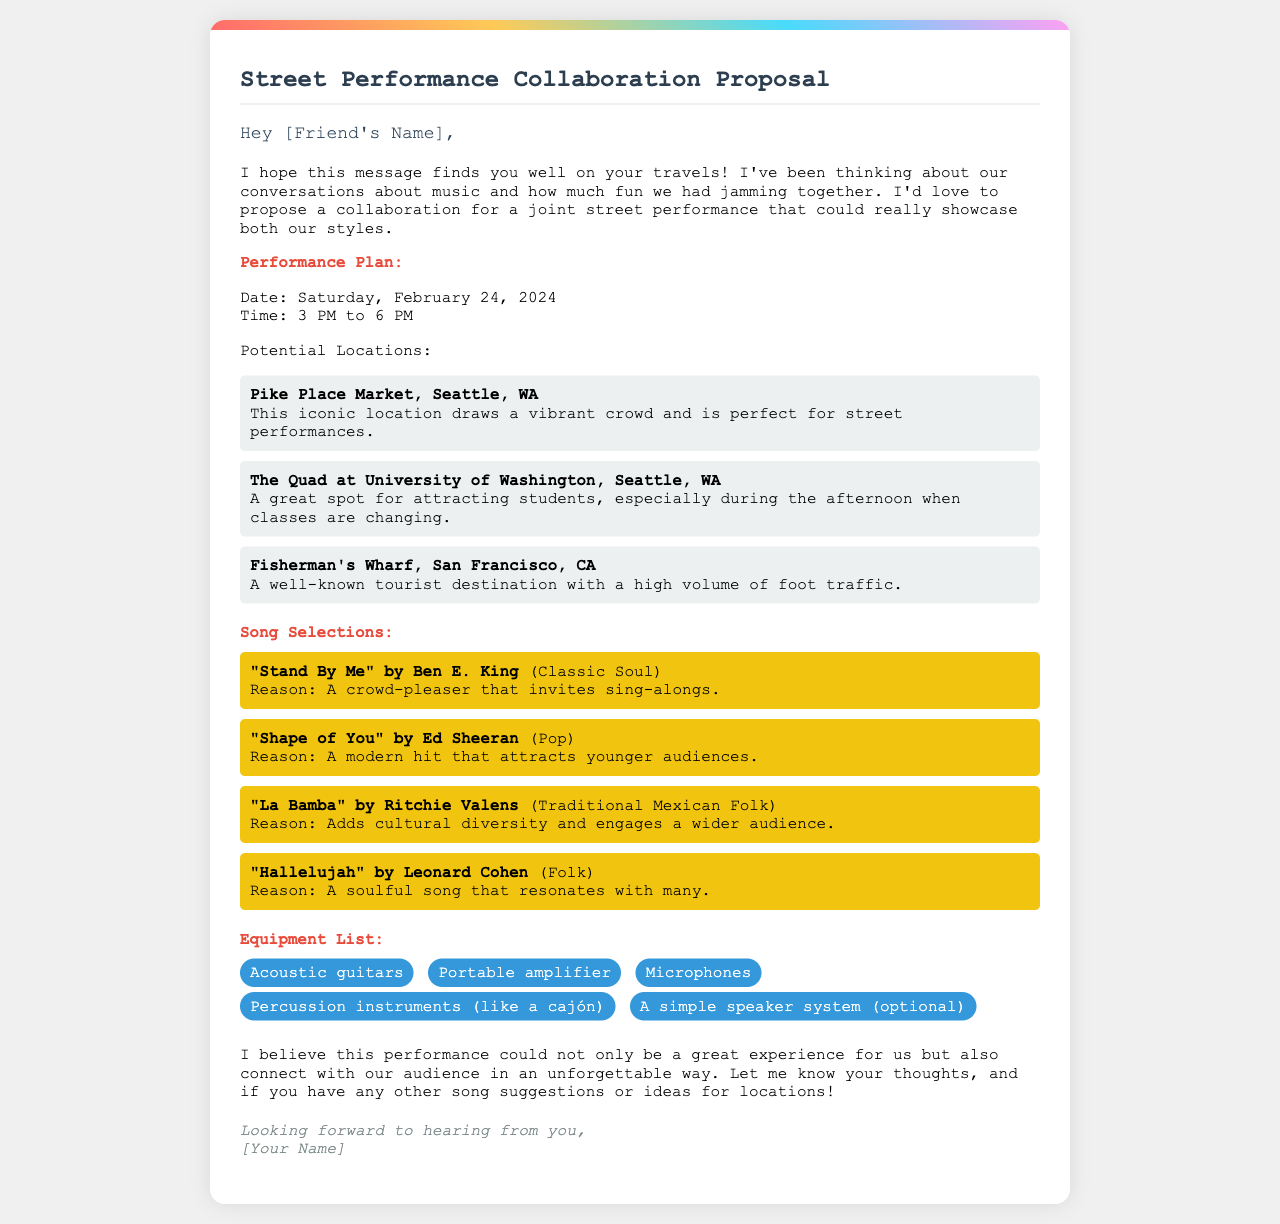What is the date of the proposed performance? The document states the proposed performance date is listed in the performance plan section.
Answer: Saturday, February 24, 2024 What is the time for the street performance? The time for the performance is mentioned in the performance plan section.
Answer: 3 PM to 6 PM Which location is known for drawing a vibrant crowd? This information is found in the section discussing potential locations.
Answer: Pike Place Market, Seattle, WA What song by Ed Sheeran is included in the selections? The song list includes various selections with the artist names noted.
Answer: "Shape of You" How many potential locations are listed in the document? The number of locations is mentioned in the performance plan section.
Answer: Three What type of instruments are listed under the equipment? The equipment list specifies certain types of instruments.
Answer: Acoustic guitars What is the reason for selecting "Hallelujah" by Leonard Cohen? The reasoning for each song selection is provided in the song selections section.
Answer: A soulful song that resonates with many What color is the background of the letter? The document describes the styling of the letter's background.
Answer: White 